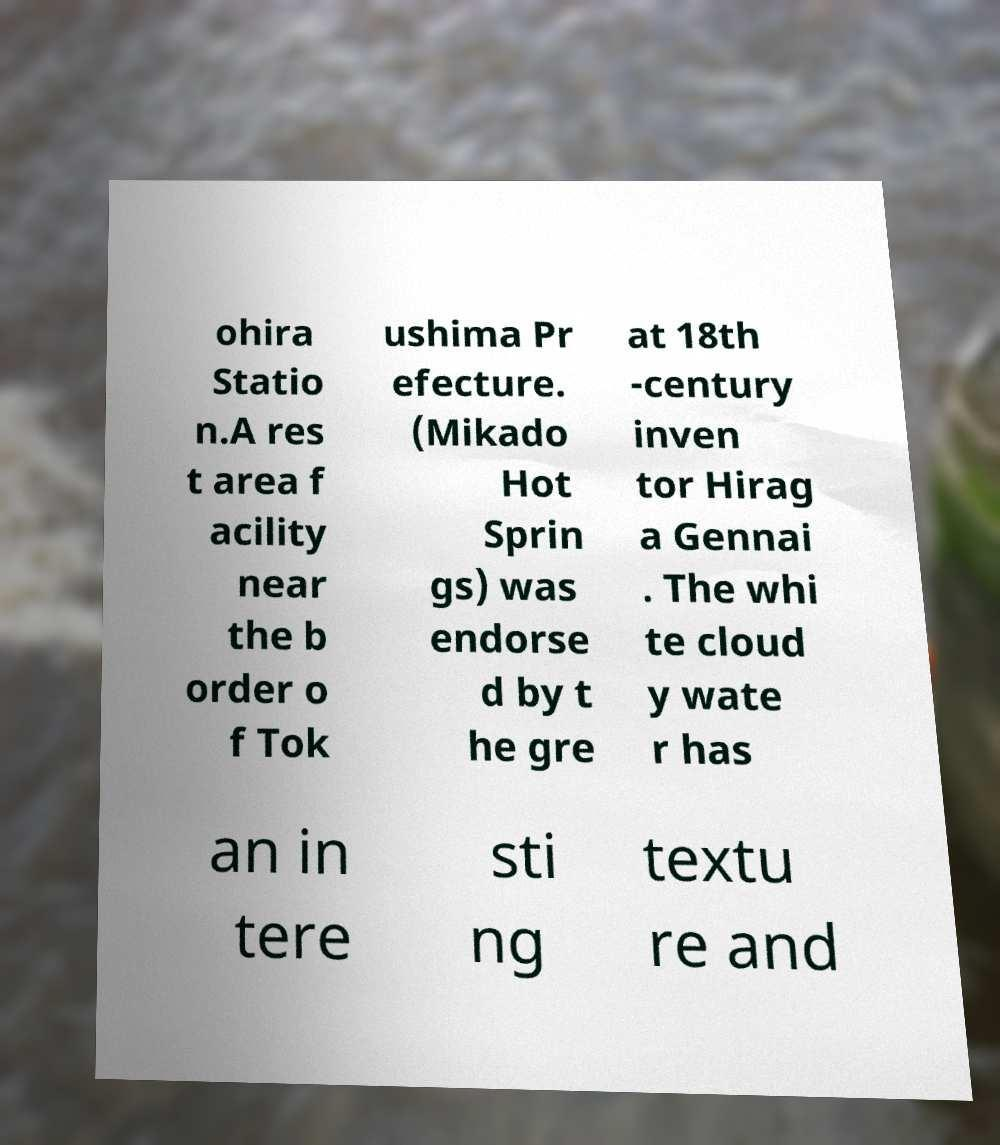Could you assist in decoding the text presented in this image and type it out clearly? ohira Statio n.A res t area f acility near the b order o f Tok ushima Pr efecture. (Mikado Hot Sprin gs) was endorse d by t he gre at 18th -century inven tor Hirag a Gennai . The whi te cloud y wate r has an in tere sti ng textu re and 